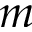<formula> <loc_0><loc_0><loc_500><loc_500>m</formula> 